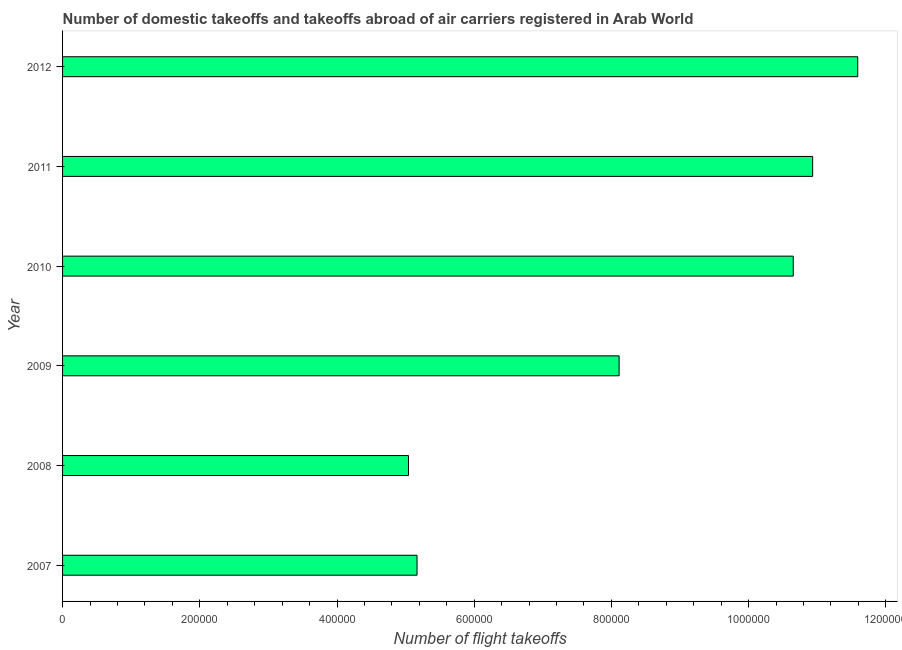Does the graph contain any zero values?
Your answer should be compact. No. What is the title of the graph?
Your response must be concise. Number of domestic takeoffs and takeoffs abroad of air carriers registered in Arab World. What is the label or title of the X-axis?
Make the answer very short. Number of flight takeoffs. What is the label or title of the Y-axis?
Your response must be concise. Year. What is the number of flight takeoffs in 2009?
Your response must be concise. 8.11e+05. Across all years, what is the maximum number of flight takeoffs?
Ensure brevity in your answer.  1.16e+06. Across all years, what is the minimum number of flight takeoffs?
Offer a terse response. 5.04e+05. In which year was the number of flight takeoffs maximum?
Provide a short and direct response. 2012. In which year was the number of flight takeoffs minimum?
Ensure brevity in your answer.  2008. What is the sum of the number of flight takeoffs?
Your answer should be compact. 5.15e+06. What is the difference between the number of flight takeoffs in 2008 and 2010?
Give a very brief answer. -5.61e+05. What is the average number of flight takeoffs per year?
Make the answer very short. 8.58e+05. What is the median number of flight takeoffs?
Offer a terse response. 9.38e+05. In how many years, is the number of flight takeoffs greater than 440000 ?
Give a very brief answer. 6. What is the ratio of the number of flight takeoffs in 2010 to that in 2012?
Give a very brief answer. 0.92. Is the number of flight takeoffs in 2009 less than that in 2011?
Make the answer very short. Yes. Is the difference between the number of flight takeoffs in 2007 and 2012 greater than the difference between any two years?
Keep it short and to the point. No. What is the difference between the highest and the second highest number of flight takeoffs?
Give a very brief answer. 6.57e+04. What is the difference between the highest and the lowest number of flight takeoffs?
Offer a very short reply. 6.55e+05. How many bars are there?
Your answer should be very brief. 6. Are all the bars in the graph horizontal?
Provide a short and direct response. Yes. Are the values on the major ticks of X-axis written in scientific E-notation?
Give a very brief answer. No. What is the Number of flight takeoffs of 2007?
Ensure brevity in your answer.  5.17e+05. What is the Number of flight takeoffs in 2008?
Your response must be concise. 5.04e+05. What is the Number of flight takeoffs of 2009?
Keep it short and to the point. 8.11e+05. What is the Number of flight takeoffs of 2010?
Give a very brief answer. 1.07e+06. What is the Number of flight takeoffs of 2011?
Your answer should be very brief. 1.09e+06. What is the Number of flight takeoffs in 2012?
Your answer should be compact. 1.16e+06. What is the difference between the Number of flight takeoffs in 2007 and 2008?
Offer a very short reply. 1.25e+04. What is the difference between the Number of flight takeoffs in 2007 and 2009?
Offer a terse response. -2.95e+05. What is the difference between the Number of flight takeoffs in 2007 and 2010?
Offer a terse response. -5.48e+05. What is the difference between the Number of flight takeoffs in 2007 and 2011?
Make the answer very short. -5.77e+05. What is the difference between the Number of flight takeoffs in 2007 and 2012?
Your response must be concise. -6.42e+05. What is the difference between the Number of flight takeoffs in 2008 and 2009?
Ensure brevity in your answer.  -3.07e+05. What is the difference between the Number of flight takeoffs in 2008 and 2010?
Your answer should be very brief. -5.61e+05. What is the difference between the Number of flight takeoffs in 2008 and 2011?
Give a very brief answer. -5.89e+05. What is the difference between the Number of flight takeoffs in 2008 and 2012?
Your answer should be compact. -6.55e+05. What is the difference between the Number of flight takeoffs in 2009 and 2010?
Ensure brevity in your answer.  -2.54e+05. What is the difference between the Number of flight takeoffs in 2009 and 2011?
Your response must be concise. -2.82e+05. What is the difference between the Number of flight takeoffs in 2009 and 2012?
Your answer should be very brief. -3.48e+05. What is the difference between the Number of flight takeoffs in 2010 and 2011?
Your answer should be very brief. -2.83e+04. What is the difference between the Number of flight takeoffs in 2010 and 2012?
Offer a very short reply. -9.40e+04. What is the difference between the Number of flight takeoffs in 2011 and 2012?
Provide a succinct answer. -6.57e+04. What is the ratio of the Number of flight takeoffs in 2007 to that in 2008?
Your answer should be compact. 1.02. What is the ratio of the Number of flight takeoffs in 2007 to that in 2009?
Your answer should be very brief. 0.64. What is the ratio of the Number of flight takeoffs in 2007 to that in 2010?
Your answer should be compact. 0.48. What is the ratio of the Number of flight takeoffs in 2007 to that in 2011?
Your response must be concise. 0.47. What is the ratio of the Number of flight takeoffs in 2007 to that in 2012?
Offer a terse response. 0.45. What is the ratio of the Number of flight takeoffs in 2008 to that in 2009?
Offer a very short reply. 0.62. What is the ratio of the Number of flight takeoffs in 2008 to that in 2010?
Provide a succinct answer. 0.47. What is the ratio of the Number of flight takeoffs in 2008 to that in 2011?
Your answer should be compact. 0.46. What is the ratio of the Number of flight takeoffs in 2008 to that in 2012?
Your response must be concise. 0.43. What is the ratio of the Number of flight takeoffs in 2009 to that in 2010?
Make the answer very short. 0.76. What is the ratio of the Number of flight takeoffs in 2009 to that in 2011?
Make the answer very short. 0.74. What is the ratio of the Number of flight takeoffs in 2009 to that in 2012?
Provide a succinct answer. 0.7. What is the ratio of the Number of flight takeoffs in 2010 to that in 2011?
Your response must be concise. 0.97. What is the ratio of the Number of flight takeoffs in 2010 to that in 2012?
Your answer should be compact. 0.92. What is the ratio of the Number of flight takeoffs in 2011 to that in 2012?
Make the answer very short. 0.94. 